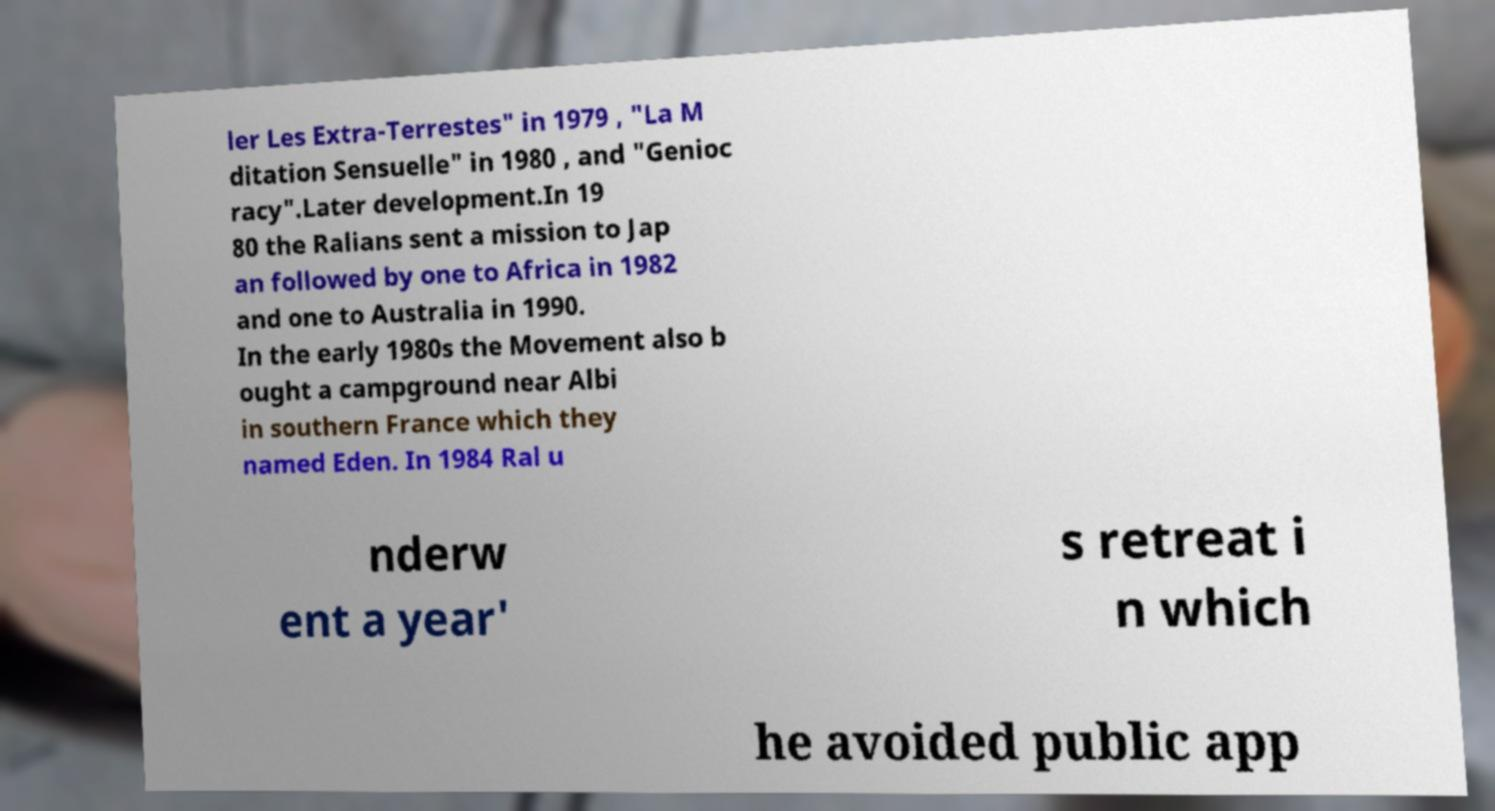Please read and relay the text visible in this image. What does it say? ler Les Extra-Terrestes" in 1979 , "La M ditation Sensuelle" in 1980 , and "Genioc racy".Later development.In 19 80 the Ralians sent a mission to Jap an followed by one to Africa in 1982 and one to Australia in 1990. In the early 1980s the Movement also b ought a campground near Albi in southern France which they named Eden. In 1984 Ral u nderw ent a year' s retreat i n which he avoided public app 